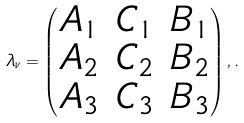<formula> <loc_0><loc_0><loc_500><loc_500>\lambda _ { \nu } = \begin{pmatrix} A _ { 1 } & C _ { 1 } & B _ { 1 } \\ A _ { 2 } & C _ { 2 } & B _ { 2 } \\ A _ { 3 } & C _ { 3 } & B _ { 3 } \end{pmatrix} , .</formula> 